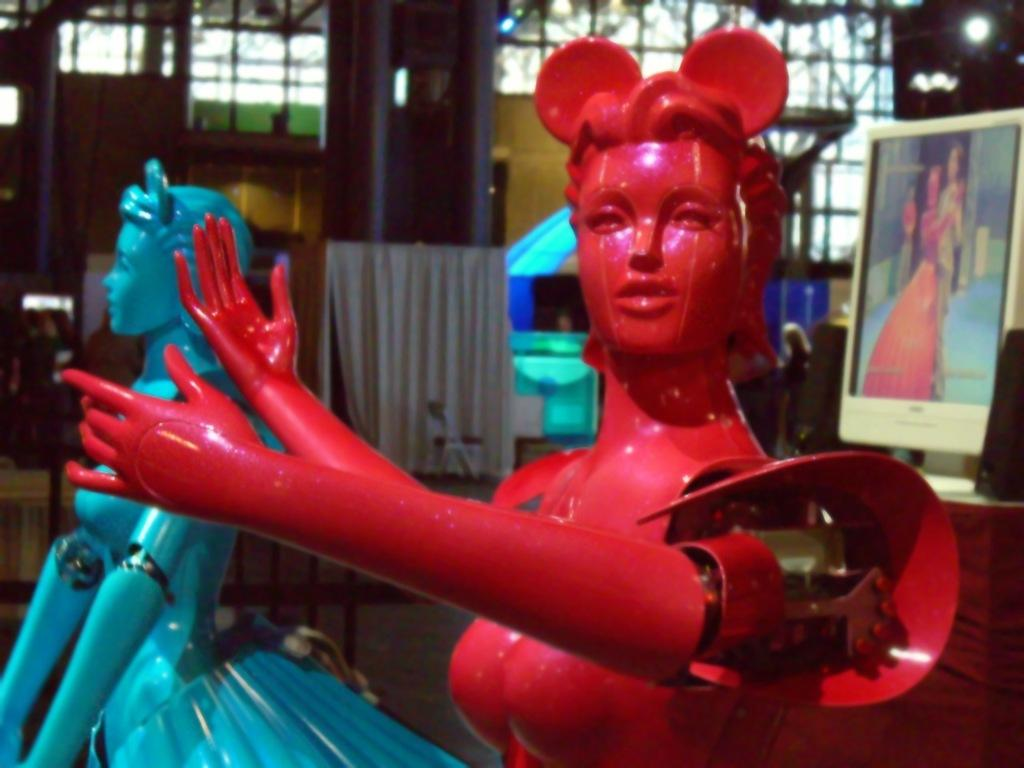What colors are represented by the objects in the image? There is a red object and a blue object in the image. What can be seen in the background of the image? There is a monitor, speakers, a light, and a white object in the background of the image. What grade is the student studying in the image? There is no student or indication of a grade in the image. What type of toys are present in the image? There are no toys present in the image. Is there a boat visible in the image? There is no boat visible in the image. 